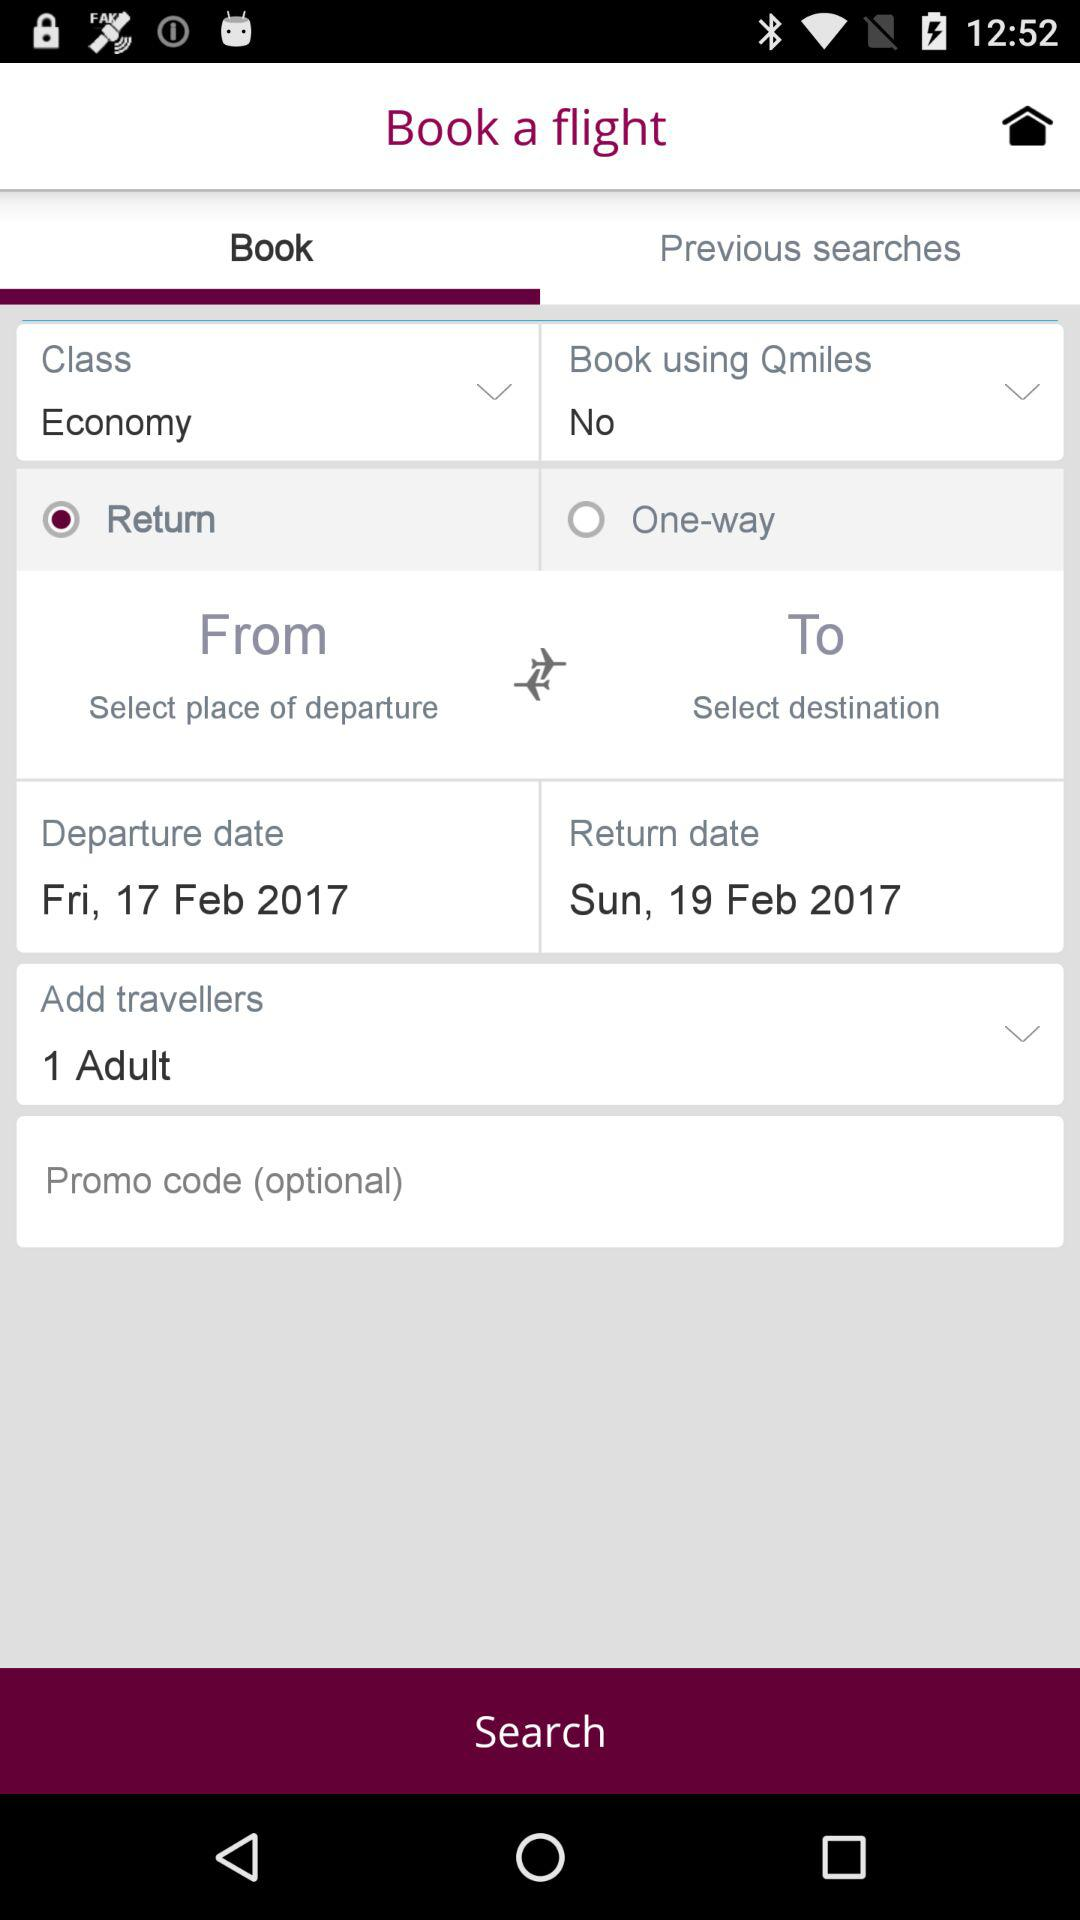What is the departure date? The departure date is Friday, February 17, 2017. 